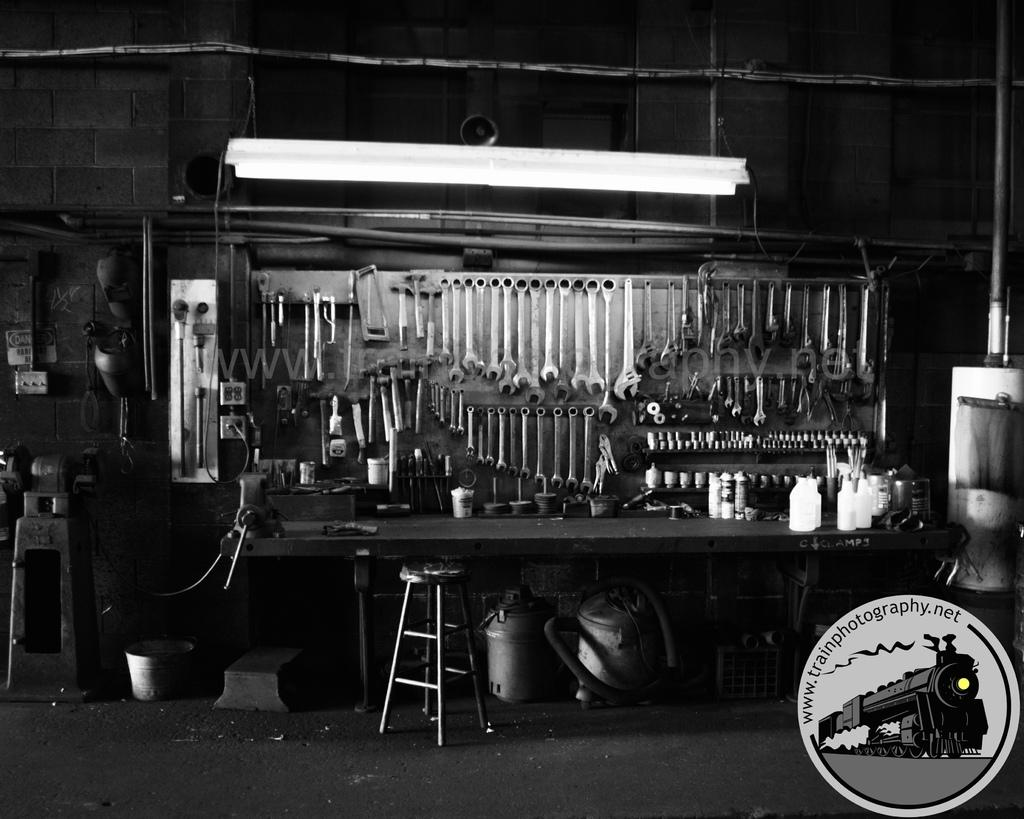What can be seen hanging in the middle of the image? There are many types of tools hanging in the middle of the image. What is located at the bottom of the image? There is a stool at the bottom of the image. What can be seen in the background of the image? There is a wall visible in the background of the image. What type of cart is present in the image? There is no cart present in the image; it features tools hanging and a stool at the bottom. 